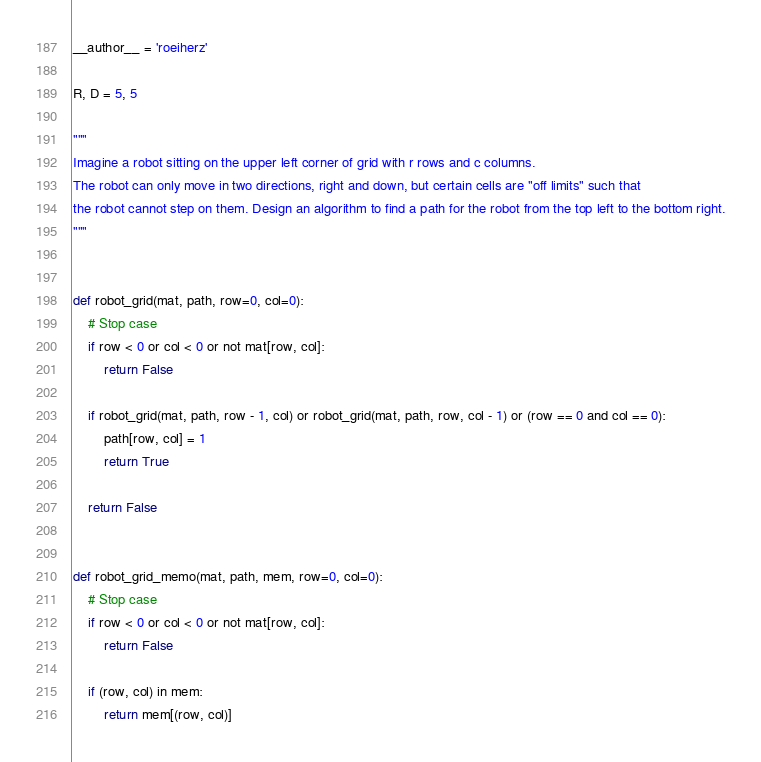<code> <loc_0><loc_0><loc_500><loc_500><_Python_>__author__ = 'roeiherz'

R, D = 5, 5

"""
Imagine a robot sitting on the upper left corner of grid with r rows and c columns. 
The robot can only move in two directions, right and down, but certain cells are "off limits" such that 
the robot cannot step on them. Design an algorithm to find a path for the robot from the top left to the bottom right.
"""


def robot_grid(mat, path, row=0, col=0):
    # Stop case
    if row < 0 or col < 0 or not mat[row, col]:
        return False

    if robot_grid(mat, path, row - 1, col) or robot_grid(mat, path, row, col - 1) or (row == 0 and col == 0):
        path[row, col] = 1
        return True

    return False


def robot_grid_memo(mat, path, mem, row=0, col=0):
    # Stop case
    if row < 0 or col < 0 or not mat[row, col]:
        return False

    if (row, col) in mem:
        return mem[(row, col)]
</code> 